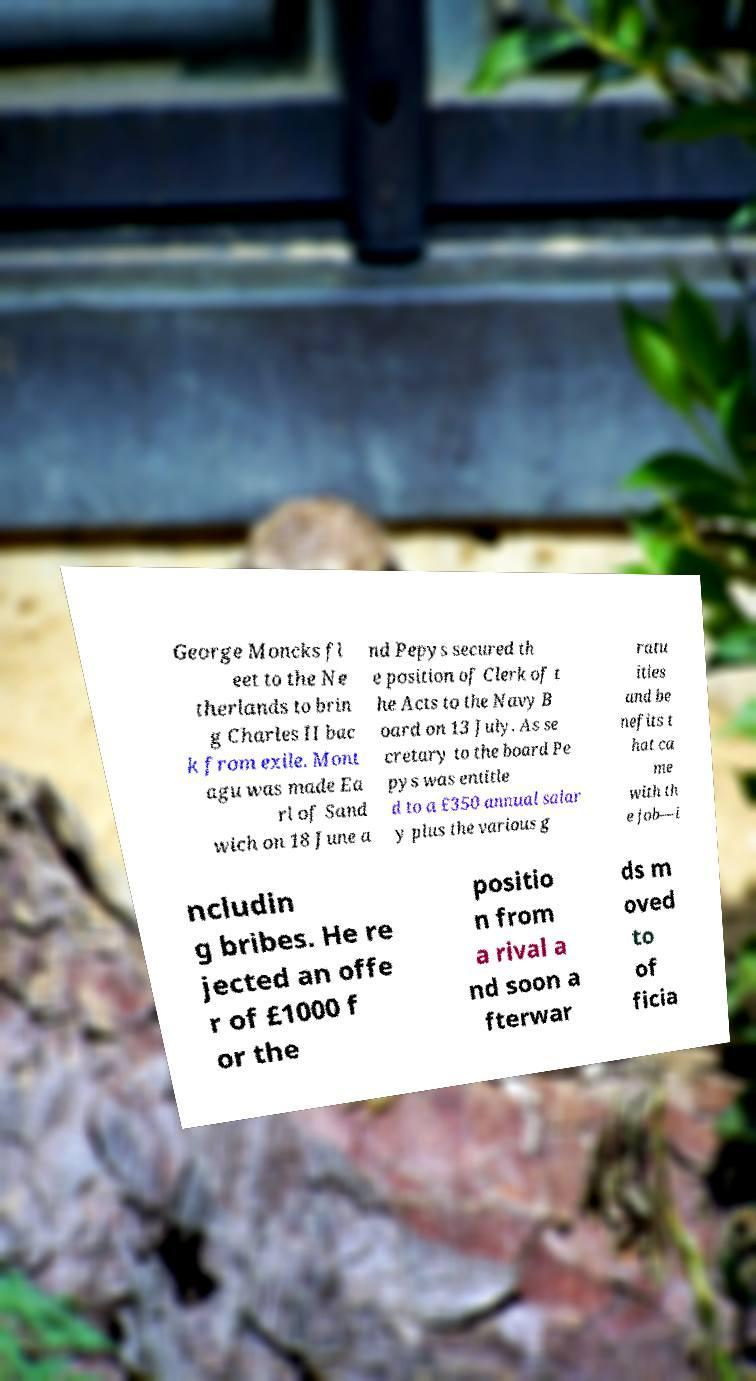Please read and relay the text visible in this image. What does it say? George Moncks fl eet to the Ne therlands to brin g Charles II bac k from exile. Mont agu was made Ea rl of Sand wich on 18 June a nd Pepys secured th e position of Clerk of t he Acts to the Navy B oard on 13 July. As se cretary to the board Pe pys was entitle d to a £350 annual salar y plus the various g ratu ities and be nefits t hat ca me with th e job—i ncludin g bribes. He re jected an offe r of £1000 f or the positio n from a rival a nd soon a fterwar ds m oved to of ficia 